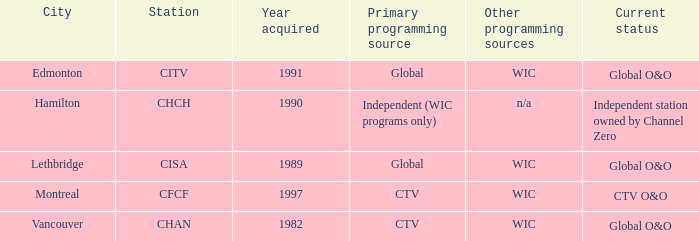How many were acquired as the chan? 1.0. 